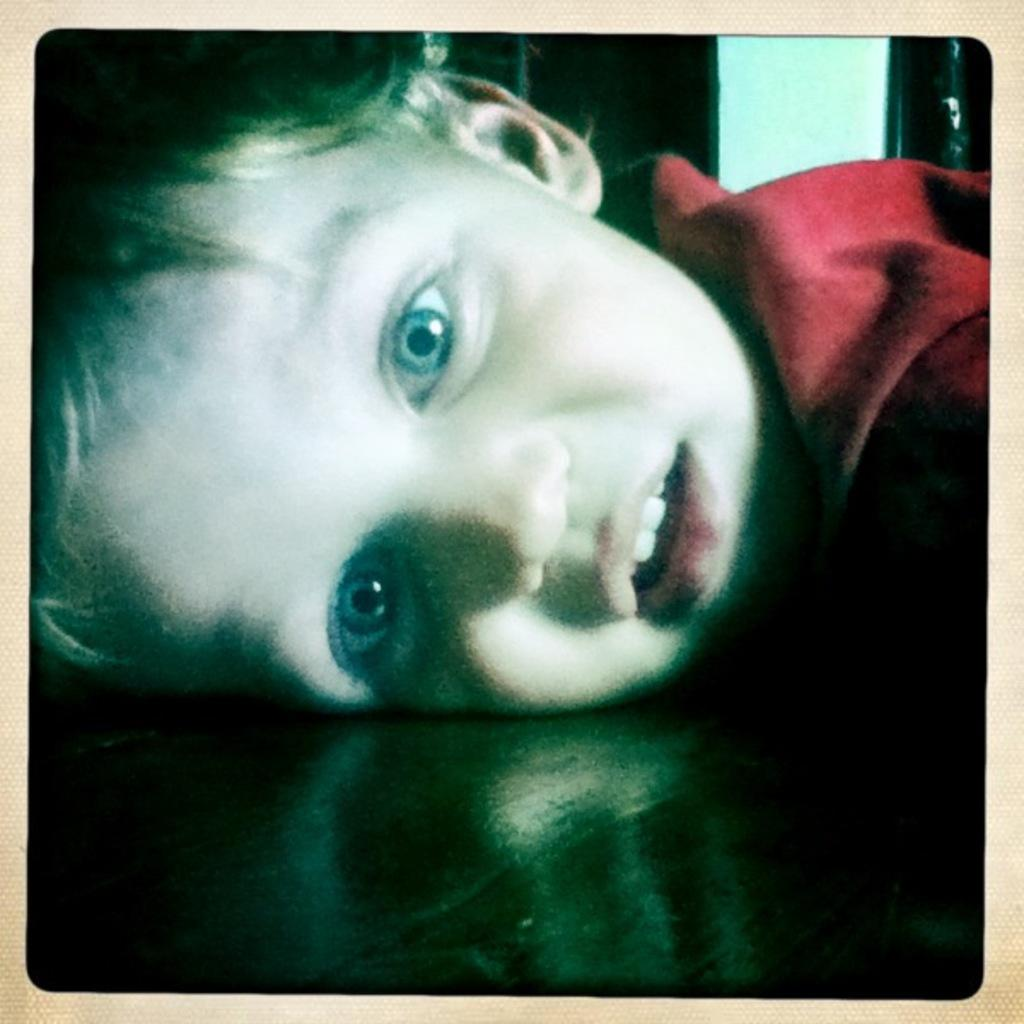Who is the main subject in the image? There is a boy in the image. What is the boy doing in the image? The boy is sleeping on a table. What is the boy wearing in the image? The boy is wearing a red shirt. What advice does the boy give to the person sitting on the seat in the image? There is no person sitting on a seat in the image, and the boy is sleeping, so he cannot give any advice. 